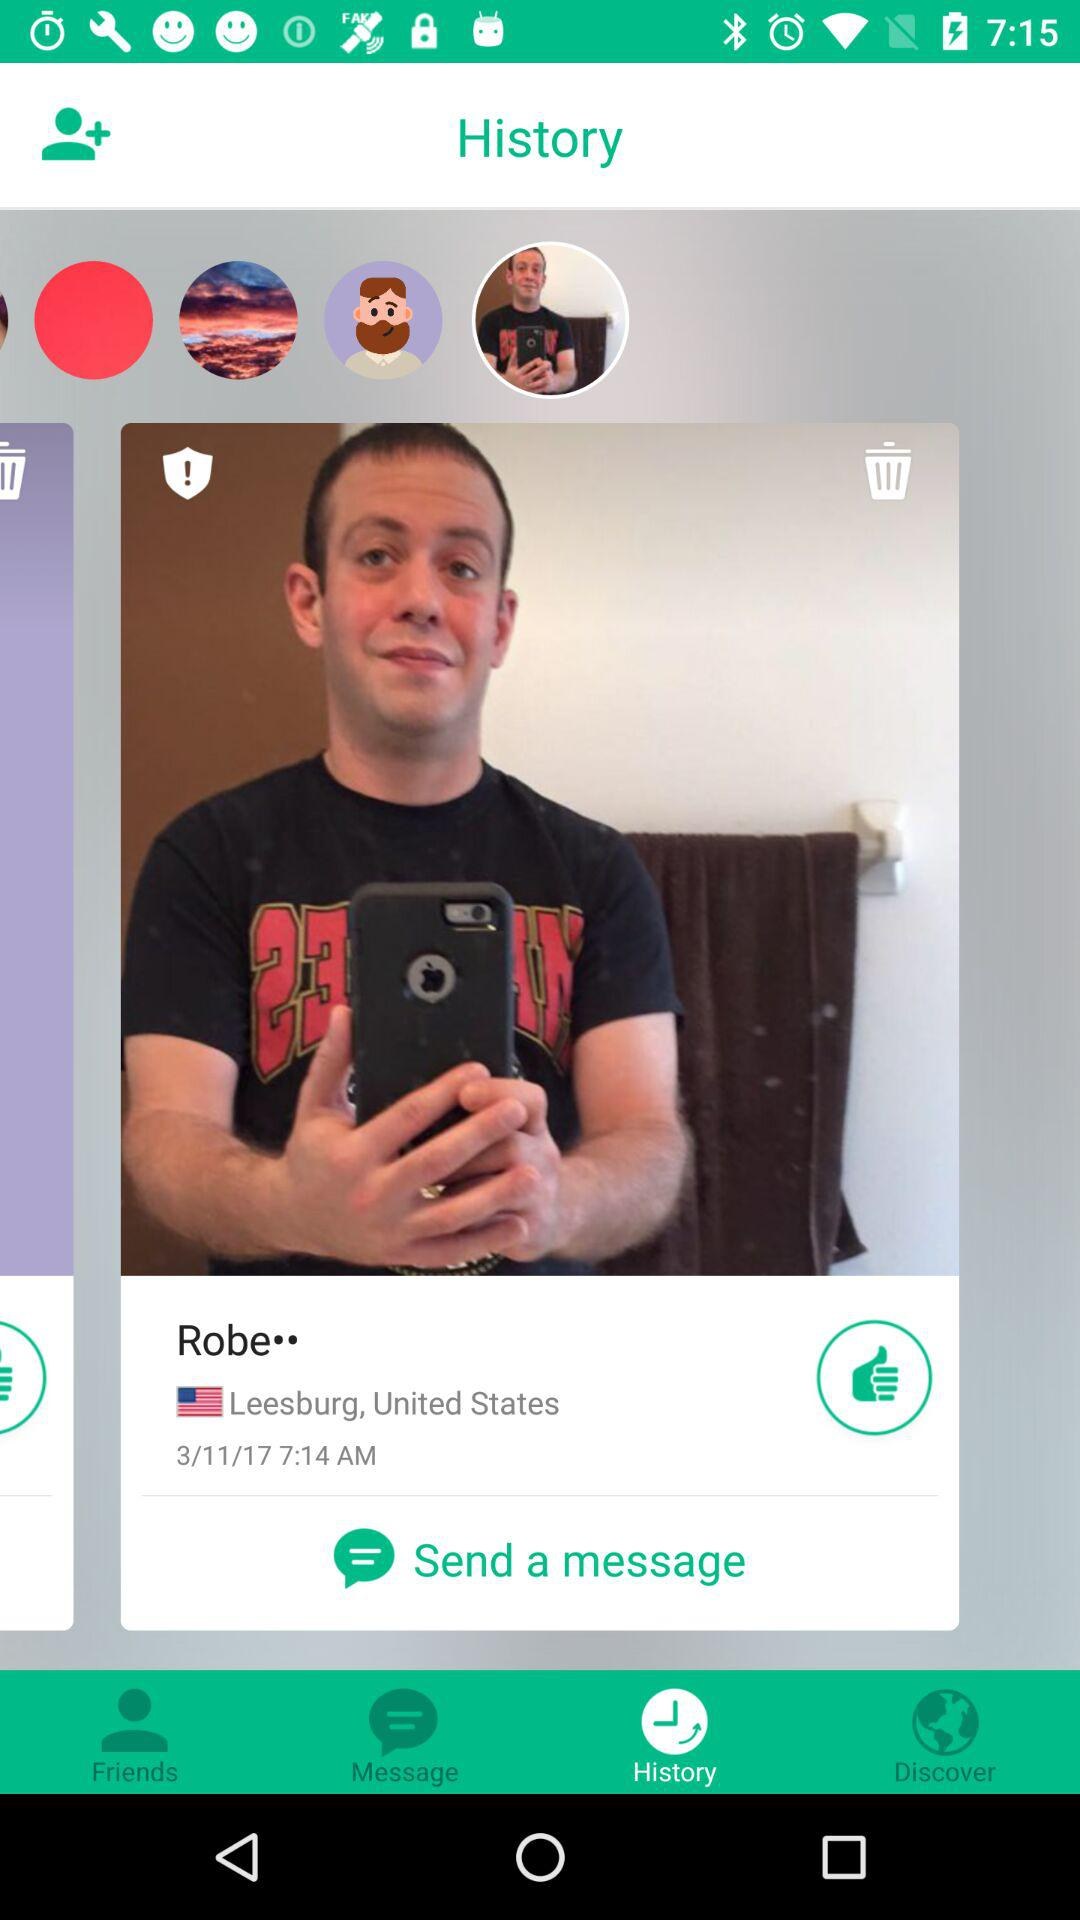What is the name of the user? The user name is Robe. 